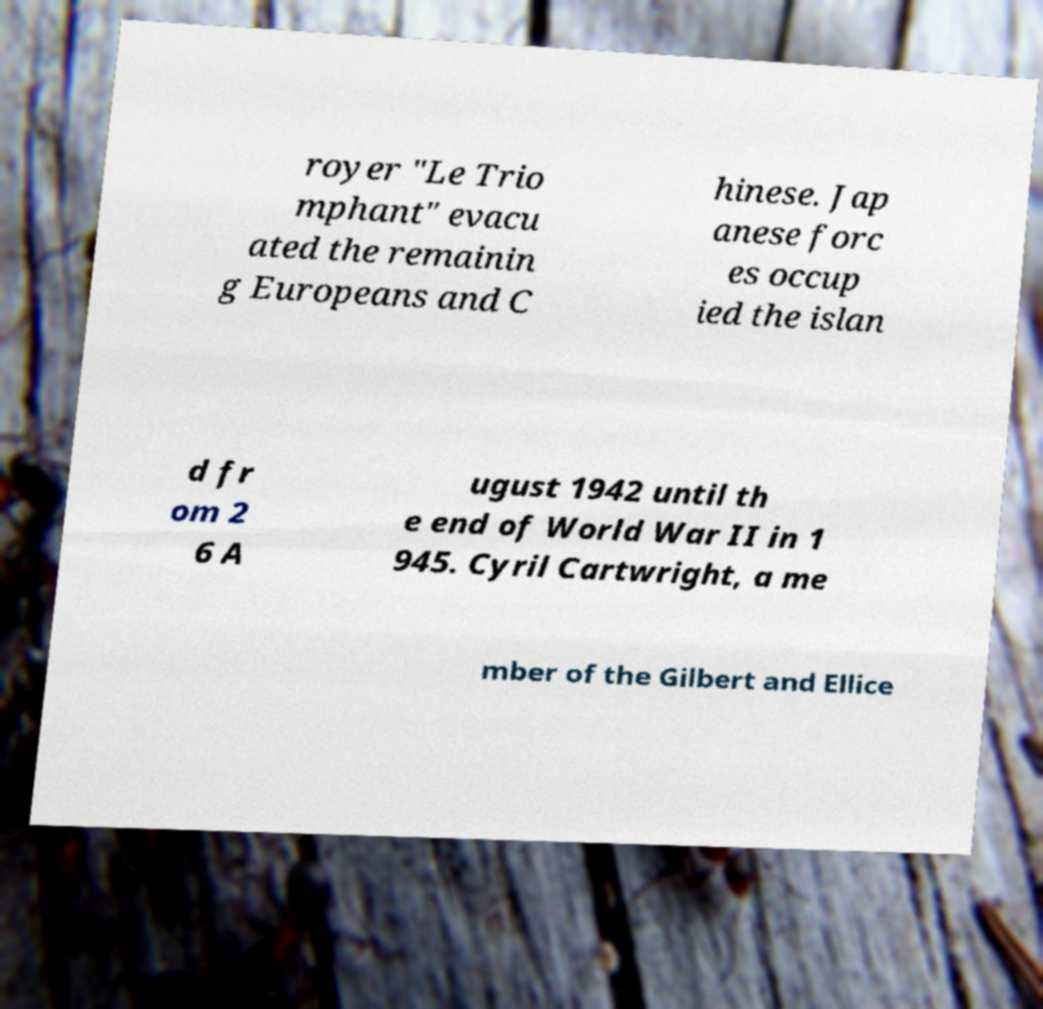Can you read and provide the text displayed in the image?This photo seems to have some interesting text. Can you extract and type it out for me? royer "Le Trio mphant" evacu ated the remainin g Europeans and C hinese. Jap anese forc es occup ied the islan d fr om 2 6 A ugust 1942 until th e end of World War II in 1 945. Cyril Cartwright, a me mber of the Gilbert and Ellice 